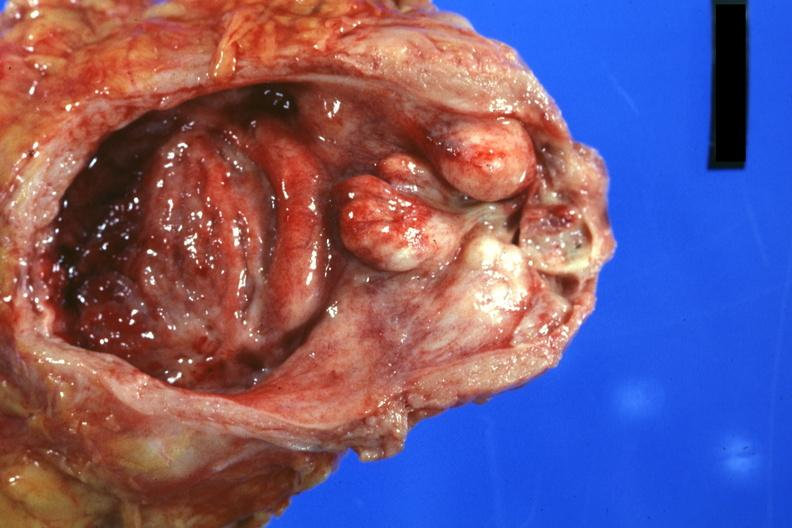s benign hyperplasia present?
Answer the question using a single word or phrase. Yes 